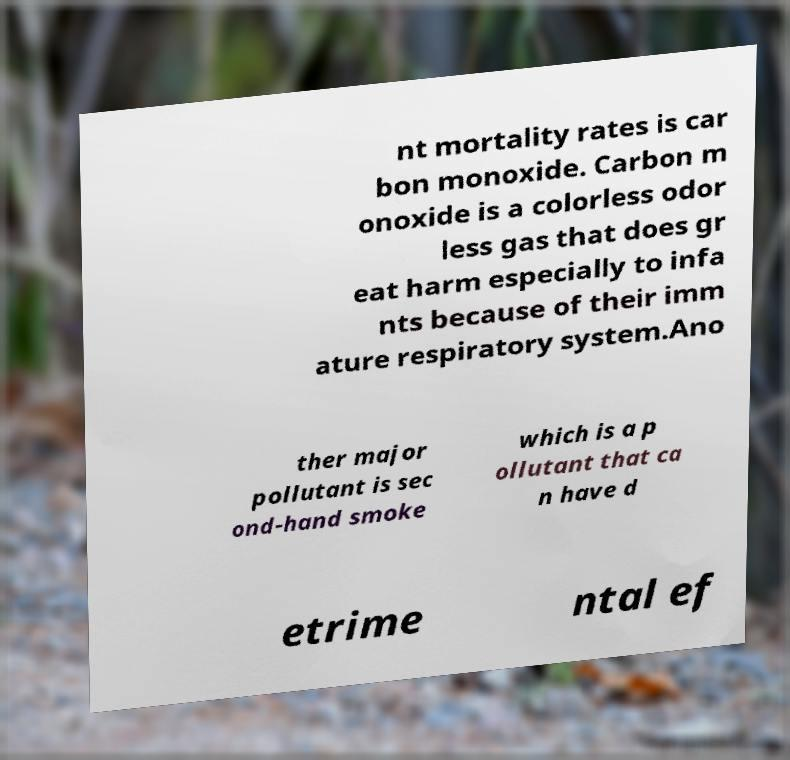For documentation purposes, I need the text within this image transcribed. Could you provide that? nt mortality rates is car bon monoxide. Carbon m onoxide is a colorless odor less gas that does gr eat harm especially to infa nts because of their imm ature respiratory system.Ano ther major pollutant is sec ond-hand smoke which is a p ollutant that ca n have d etrime ntal ef 